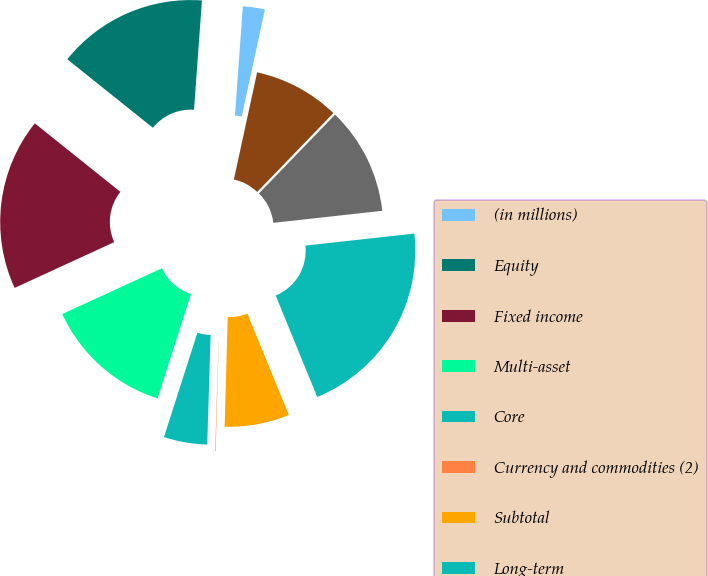Convert chart. <chart><loc_0><loc_0><loc_500><loc_500><pie_chart><fcel>(in millions)<fcel>Equity<fcel>Fixed income<fcel>Multi-asset<fcel>Core<fcel>Currency and commodities (2)<fcel>Subtotal<fcel>Long-term<fcel>Cash management<fcel>Advisory (1)<nl><fcel>2.25%<fcel>15.41%<fcel>17.6%<fcel>13.21%<fcel>4.44%<fcel>0.05%<fcel>6.63%<fcel>20.57%<fcel>11.02%<fcel>8.83%<nl></chart> 